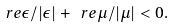Convert formula to latex. <formula><loc_0><loc_0><loc_500><loc_500>\ r e \epsilon / | \epsilon | + \ r e \mu / | \mu | < 0 .</formula> 